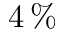Convert formula to latex. <formula><loc_0><loc_0><loc_500><loc_500>4 \, \%</formula> 